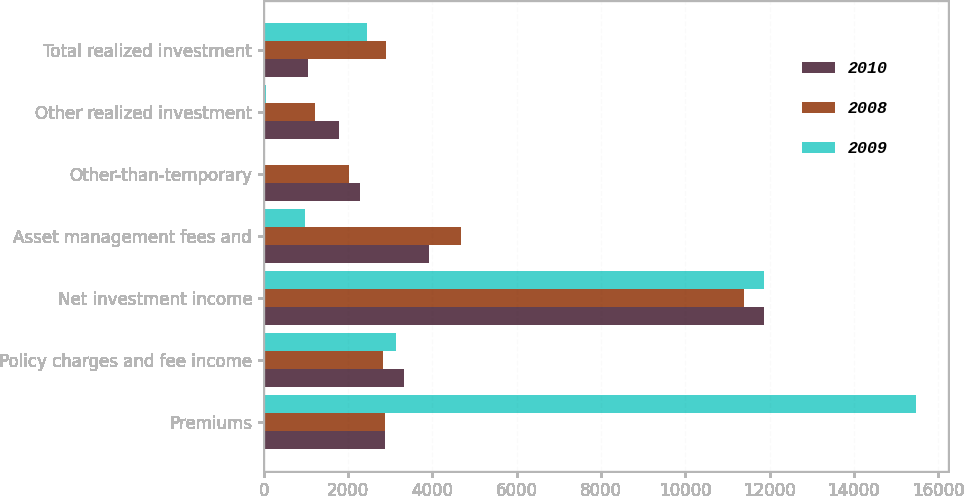Convert chart. <chart><loc_0><loc_0><loc_500><loc_500><stacked_bar_chart><ecel><fcel>Premiums<fcel>Policy charges and fee income<fcel>Net investment income<fcel>Asset management fees and<fcel>Other-than-temporary<fcel>Other realized investment<fcel>Total realized investment<nl><fcel>2010<fcel>2865<fcel>3321<fcel>11875<fcel>3908<fcel>2284<fcel>1782<fcel>1050<nl><fcel>2008<fcel>2865<fcel>2833<fcel>11403<fcel>4682<fcel>2027<fcel>1203<fcel>2897<nl><fcel>2009<fcel>15468<fcel>3138<fcel>11861<fcel>980<fcel>0<fcel>60<fcel>2457<nl></chart> 